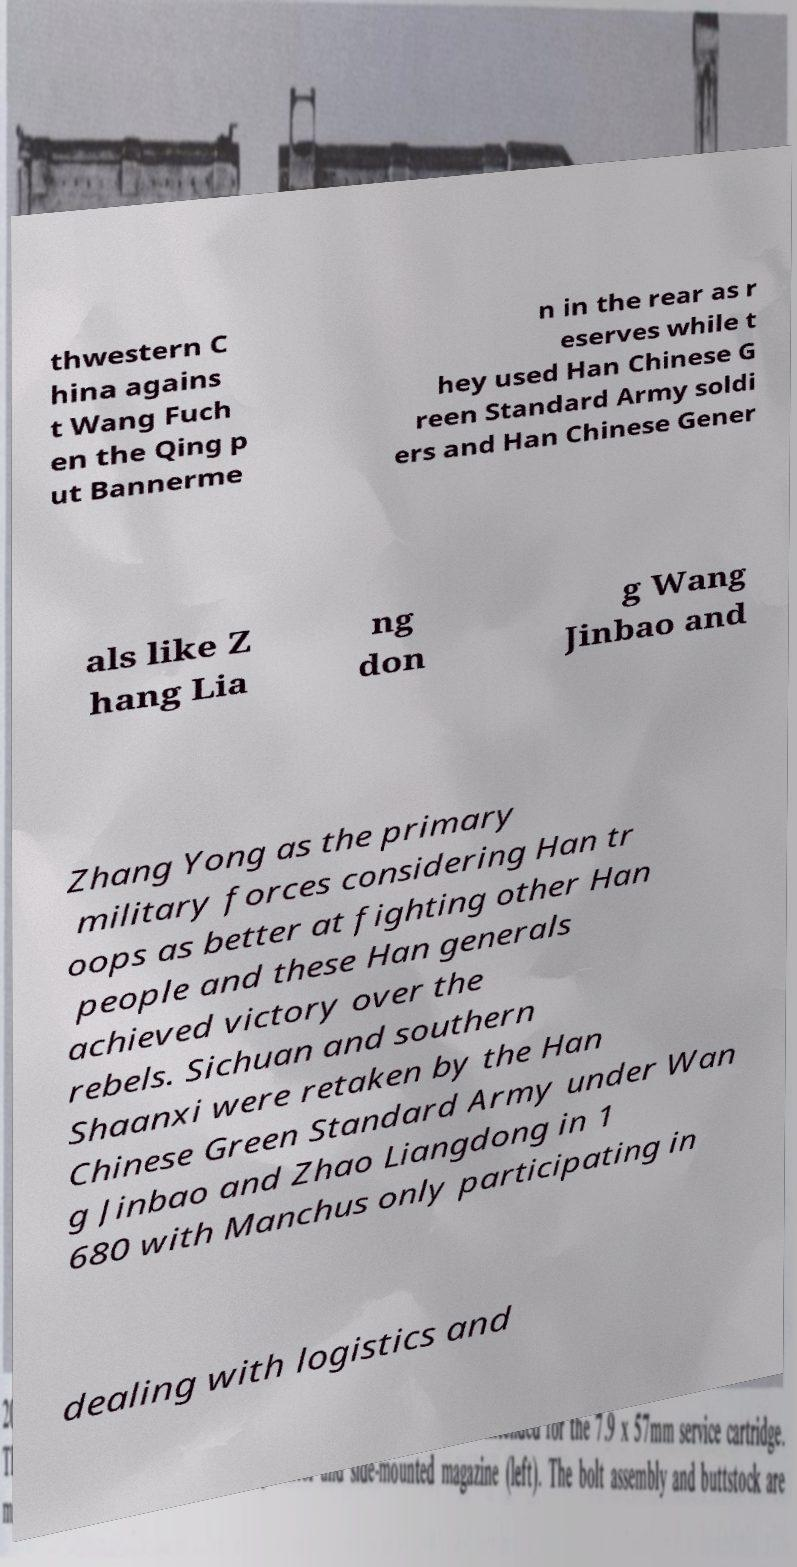What messages or text are displayed in this image? I need them in a readable, typed format. thwestern C hina agains t Wang Fuch en the Qing p ut Bannerme n in the rear as r eserves while t hey used Han Chinese G reen Standard Army soldi ers and Han Chinese Gener als like Z hang Lia ng don g Wang Jinbao and Zhang Yong as the primary military forces considering Han tr oops as better at fighting other Han people and these Han generals achieved victory over the rebels. Sichuan and southern Shaanxi were retaken by the Han Chinese Green Standard Army under Wan g Jinbao and Zhao Liangdong in 1 680 with Manchus only participating in dealing with logistics and 